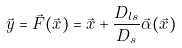<formula> <loc_0><loc_0><loc_500><loc_500>\vec { y } = \vec { F } ( \vec { x } ) = \vec { x } + \frac { D _ { l s } } { D _ { s } } \vec { \alpha } ( \vec { x } )</formula> 